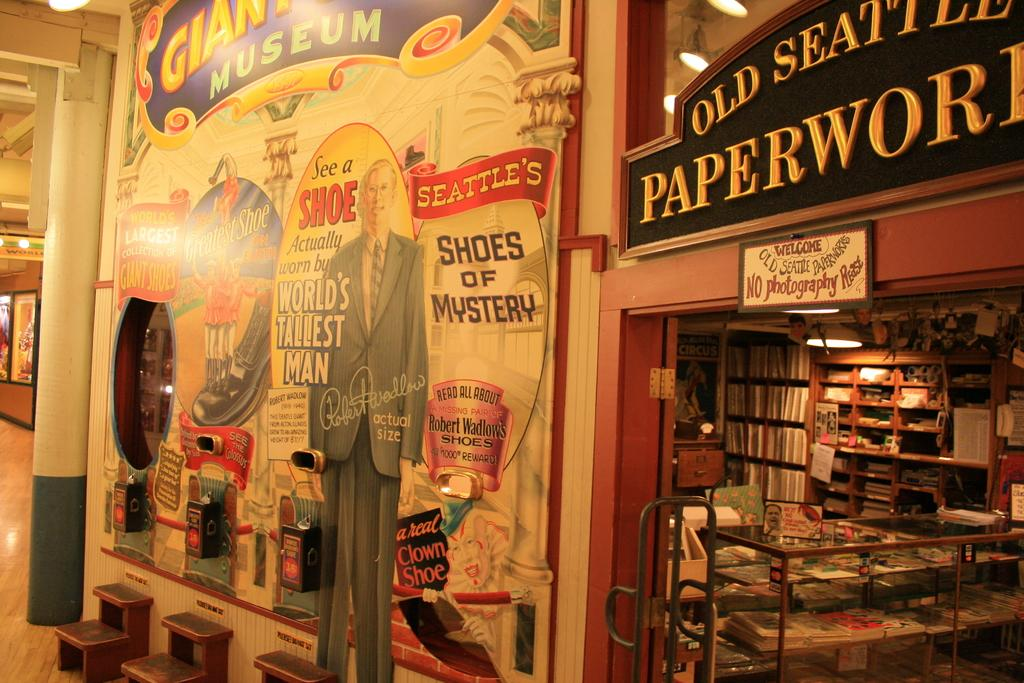Provide a one-sentence caption for the provided image. A store front with lots of books called Old Seattle Paperwork. 